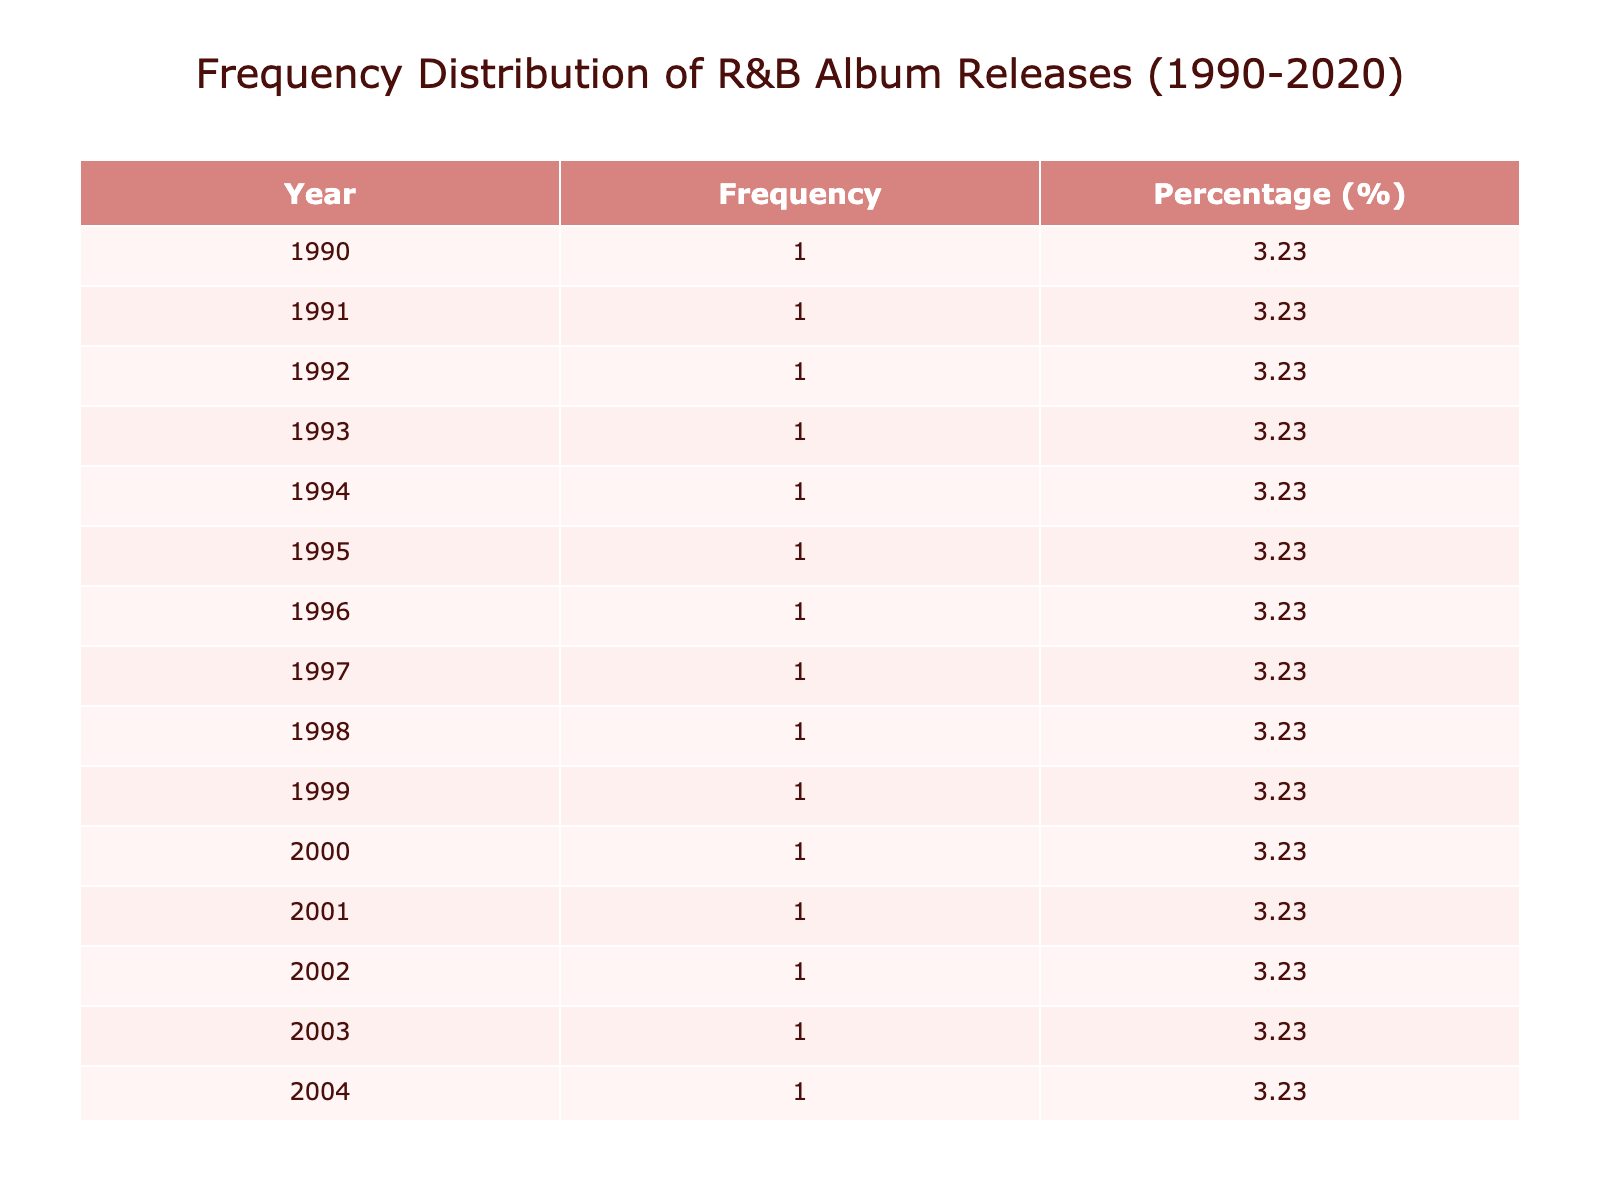What year had the most R&B album releases? By looking at the Frequency column in the table, we can identify the year with the highest frequency. For this dataset, the year 2001 has the highest frequency of album releases, with a total of 3 albums.
Answer: 2001 How many albums were released in 1997? By referring to the table, we see that in 1997 there is 1 album listed (Life After Death by The Notorious B.I.G.). Therefore, the number of albums in that year is 1.
Answer: 1 What is the percentage of album releases from the year 2015 compared to the total? We look at the frequency of 2015, which is 1 album. To find the percentage, we calculate: (1 album / 31 total albums) * 100 = 3.23%. Thus, the percentage is rounded to 3.23%.
Answer: 3.23% Are there any years with exactly 2 album releases? By examining the Frequency column, we see that the years 1994, 2002, 2005, and 2006 all have exactly 2 album releases. Therefore, the answer is yes.
Answer: Yes What is the average number of album releases per year from 1990 to 2020? To find the average, we sum up the total number of albums, which is 31, and divide it by the number of years, which is 31 (from 1990 to 2020). Therefore, the average is calculated to be 31/31 = 1.
Answer: 1 